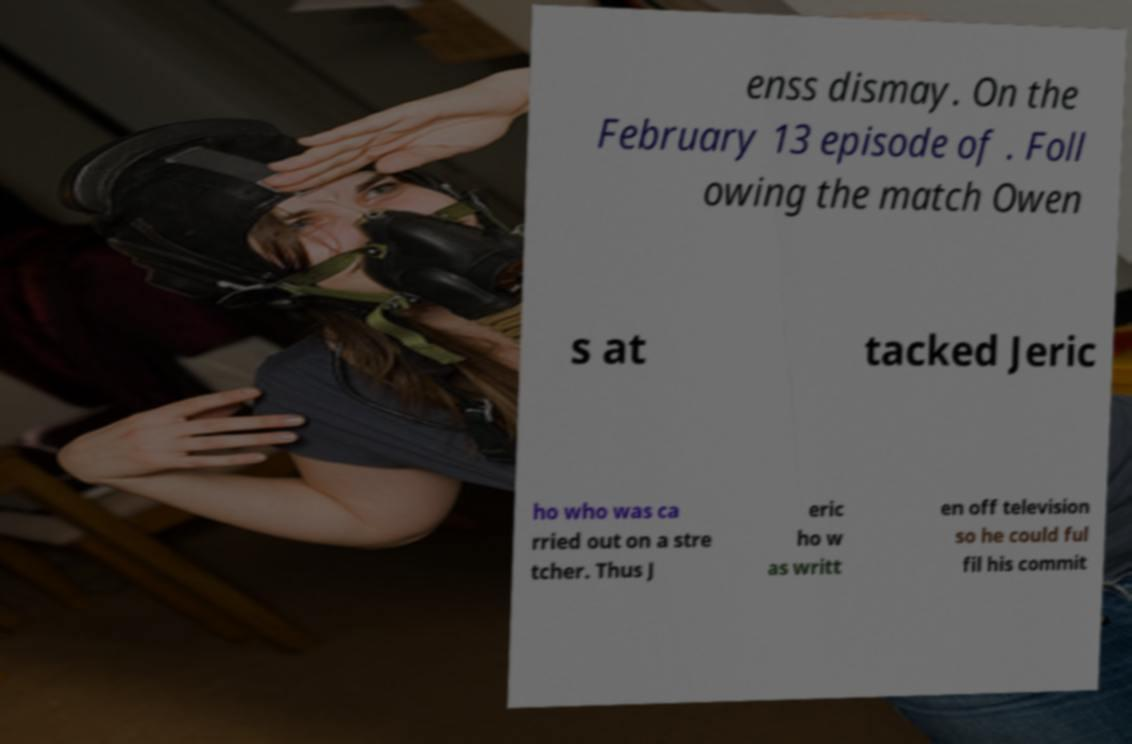Can you read and provide the text displayed in the image?This photo seems to have some interesting text. Can you extract and type it out for me? enss dismay. On the February 13 episode of . Foll owing the match Owen s at tacked Jeric ho who was ca rried out on a stre tcher. Thus J eric ho w as writt en off television so he could ful fil his commit 